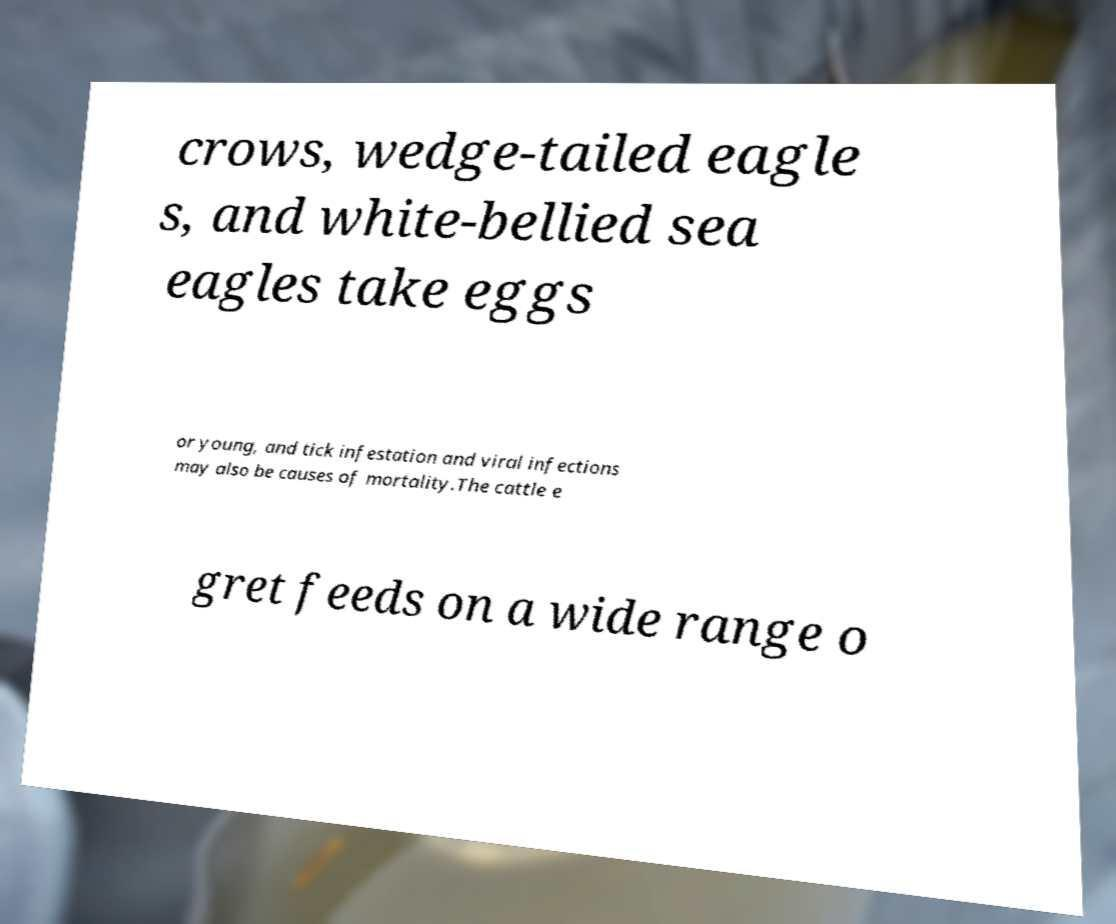I need the written content from this picture converted into text. Can you do that? crows, wedge-tailed eagle s, and white-bellied sea eagles take eggs or young, and tick infestation and viral infections may also be causes of mortality.The cattle e gret feeds on a wide range o 